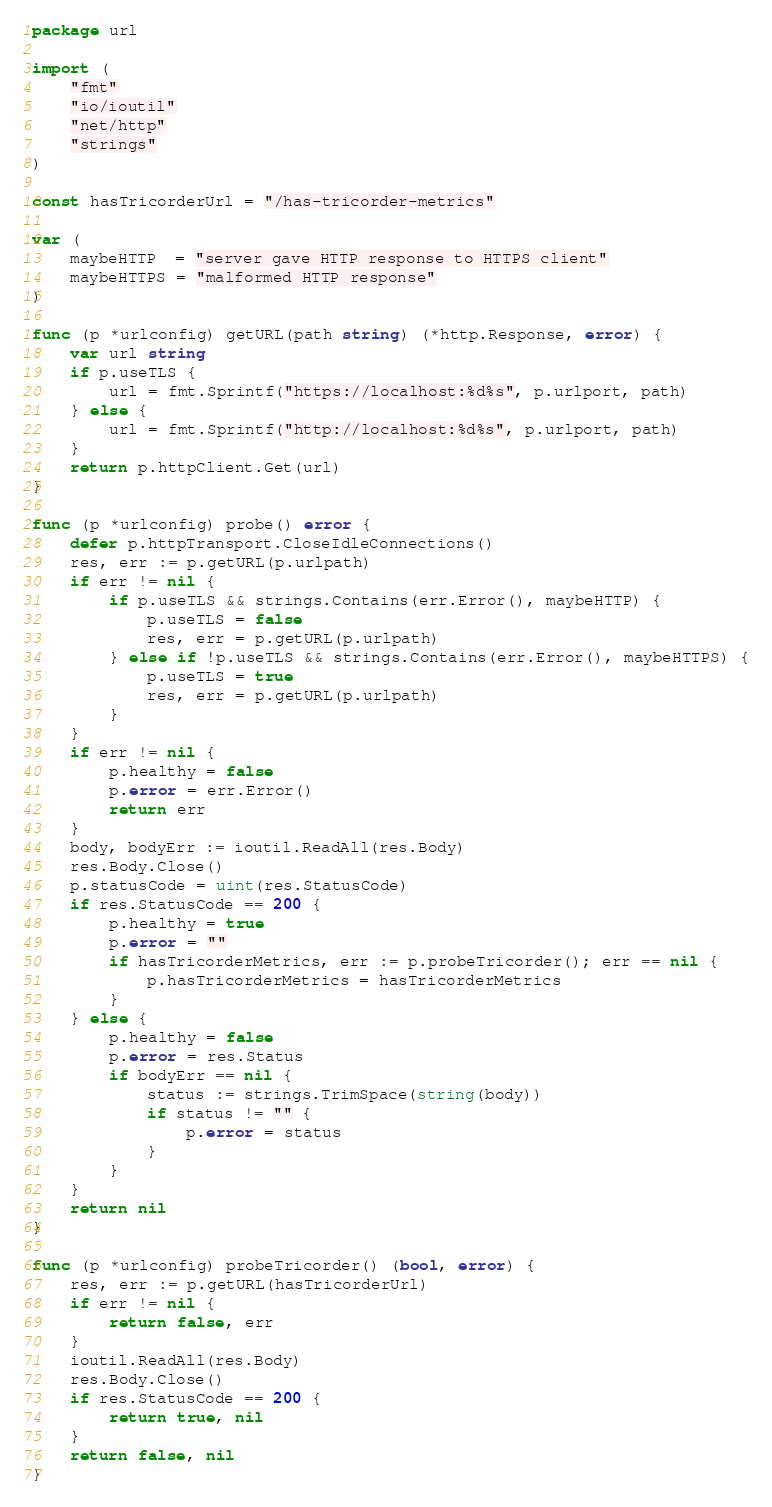<code> <loc_0><loc_0><loc_500><loc_500><_Go_>package url

import (
	"fmt"
	"io/ioutil"
	"net/http"
	"strings"
)

const hasTricorderUrl = "/has-tricorder-metrics"

var (
	maybeHTTP  = "server gave HTTP response to HTTPS client"
	maybeHTTPS = "malformed HTTP response"
)

func (p *urlconfig) getURL(path string) (*http.Response, error) {
	var url string
	if p.useTLS {
		url = fmt.Sprintf("https://localhost:%d%s", p.urlport, path)
	} else {
		url = fmt.Sprintf("http://localhost:%d%s", p.urlport, path)
	}
	return p.httpClient.Get(url)
}

func (p *urlconfig) probe() error {
	defer p.httpTransport.CloseIdleConnections()
	res, err := p.getURL(p.urlpath)
	if err != nil {
		if p.useTLS && strings.Contains(err.Error(), maybeHTTP) {
			p.useTLS = false
			res, err = p.getURL(p.urlpath)
		} else if !p.useTLS && strings.Contains(err.Error(), maybeHTTPS) {
			p.useTLS = true
			res, err = p.getURL(p.urlpath)
		}
	}
	if err != nil {
		p.healthy = false
		p.error = err.Error()
		return err
	}
	body, bodyErr := ioutil.ReadAll(res.Body)
	res.Body.Close()
	p.statusCode = uint(res.StatusCode)
	if res.StatusCode == 200 {
		p.healthy = true
		p.error = ""
		if hasTricorderMetrics, err := p.probeTricorder(); err == nil {
			p.hasTricorderMetrics = hasTricorderMetrics
		}
	} else {
		p.healthy = false
		p.error = res.Status
		if bodyErr == nil {
			status := strings.TrimSpace(string(body))
			if status != "" {
				p.error = status
			}
		}
	}
	return nil
}

func (p *urlconfig) probeTricorder() (bool, error) {
	res, err := p.getURL(hasTricorderUrl)
	if err != nil {
		return false, err
	}
	ioutil.ReadAll(res.Body)
	res.Body.Close()
	if res.StatusCode == 200 {
		return true, nil
	}
	return false, nil
}
</code> 